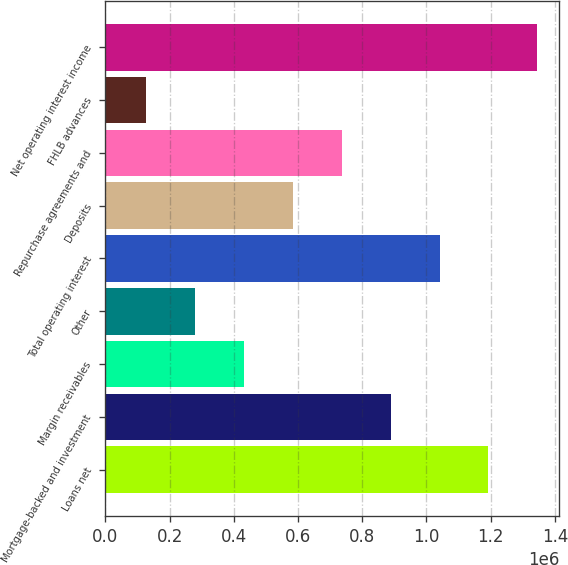Convert chart. <chart><loc_0><loc_0><loc_500><loc_500><bar_chart><fcel>Loans net<fcel>Mortgage-backed and investment<fcel>Margin receivables<fcel>Other<fcel>Total operating interest<fcel>Deposits<fcel>Repurchase agreements and<fcel>FHLB advances<fcel>Net operating interest income<nl><fcel>1.19313e+06<fcel>888380<fcel>431249<fcel>278872<fcel>1.04076e+06<fcel>583626<fcel>736003<fcel>126495<fcel>1.34551e+06<nl></chart> 